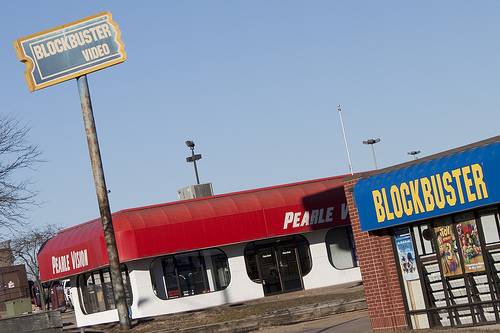<image>
Is there a sign to the left of the building? Yes. From this viewpoint, the sign is positioned to the left side relative to the building. 